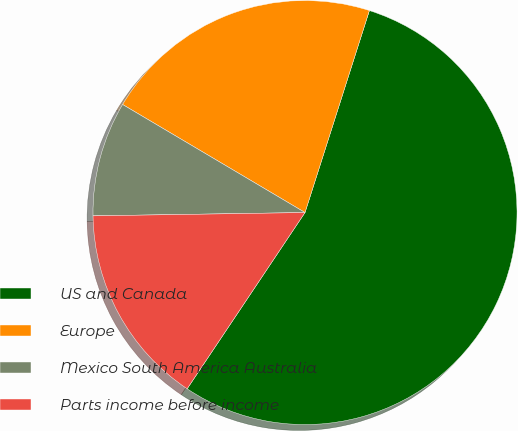Convert chart to OTSL. <chart><loc_0><loc_0><loc_500><loc_500><pie_chart><fcel>US and Canada<fcel>Europe<fcel>Mexico South America Australia<fcel>Parts income before income<nl><fcel>54.47%<fcel>21.4%<fcel>8.76%<fcel>15.37%<nl></chart> 